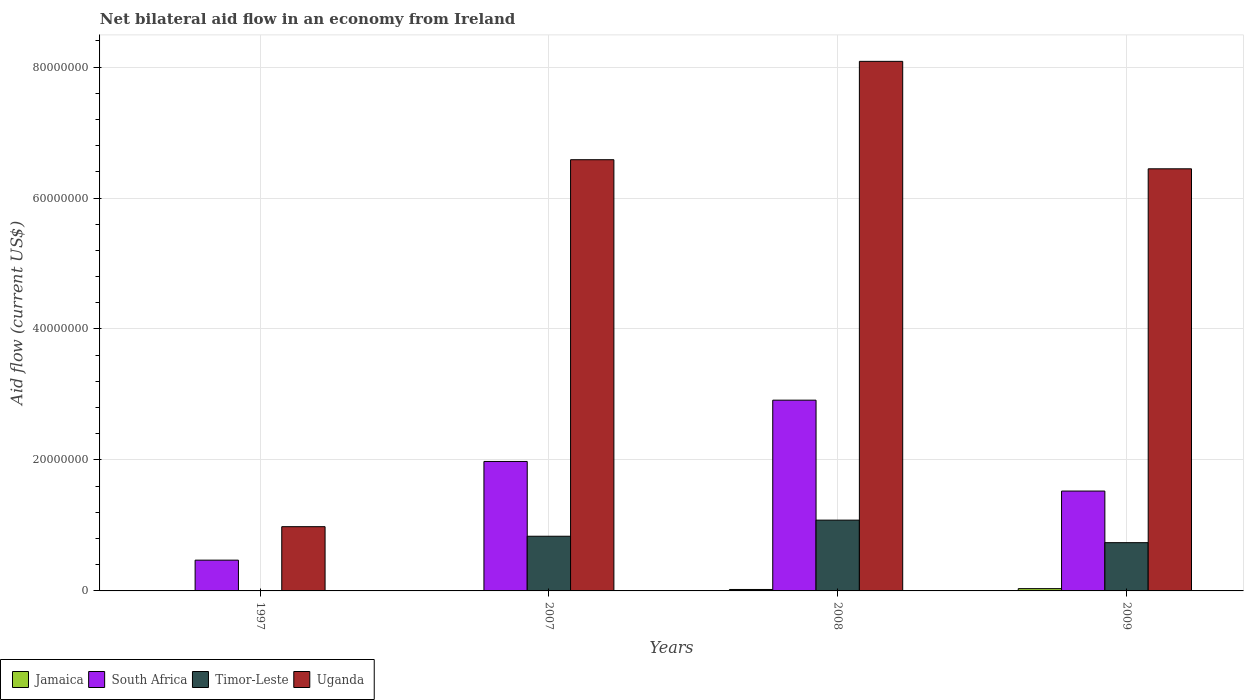Are the number of bars per tick equal to the number of legend labels?
Provide a succinct answer. Yes. Are the number of bars on each tick of the X-axis equal?
Make the answer very short. Yes. How many bars are there on the 2nd tick from the left?
Offer a very short reply. 4. How many bars are there on the 1st tick from the right?
Provide a succinct answer. 4. What is the label of the 3rd group of bars from the left?
Your answer should be very brief. 2008. In how many cases, is the number of bars for a given year not equal to the number of legend labels?
Offer a very short reply. 0. Across all years, what is the maximum net bilateral aid flow in Timor-Leste?
Provide a succinct answer. 1.08e+07. In which year was the net bilateral aid flow in Uganda minimum?
Your answer should be compact. 1997. What is the total net bilateral aid flow in South Africa in the graph?
Ensure brevity in your answer.  6.88e+07. What is the difference between the net bilateral aid flow in Timor-Leste in 1997 and that in 2007?
Provide a short and direct response. -8.30e+06. What is the difference between the net bilateral aid flow in Timor-Leste in 2008 and the net bilateral aid flow in Uganda in 1997?
Keep it short and to the point. 1.00e+06. What is the average net bilateral aid flow in Jamaica per year?
Give a very brief answer. 1.65e+05. In the year 2009, what is the difference between the net bilateral aid flow in Jamaica and net bilateral aid flow in Uganda?
Provide a short and direct response. -6.41e+07. What is the ratio of the net bilateral aid flow in Uganda in 1997 to that in 2008?
Provide a succinct answer. 0.12. What is the difference between the highest and the second highest net bilateral aid flow in Timor-Leste?
Provide a succinct answer. 2.46e+06. What is the difference between the highest and the lowest net bilateral aid flow in Timor-Leste?
Offer a very short reply. 1.08e+07. What does the 2nd bar from the left in 2008 represents?
Your answer should be compact. South Africa. What does the 4th bar from the right in 2008 represents?
Offer a terse response. Jamaica. Is it the case that in every year, the sum of the net bilateral aid flow in South Africa and net bilateral aid flow in Jamaica is greater than the net bilateral aid flow in Timor-Leste?
Offer a terse response. Yes. How many bars are there?
Provide a succinct answer. 16. Are the values on the major ticks of Y-axis written in scientific E-notation?
Offer a very short reply. No. Does the graph contain any zero values?
Offer a very short reply. No. Does the graph contain grids?
Provide a succinct answer. Yes. How many legend labels are there?
Provide a succinct answer. 4. What is the title of the graph?
Ensure brevity in your answer.  Net bilateral aid flow in an economy from Ireland. Does "Cyprus" appear as one of the legend labels in the graph?
Give a very brief answer. No. What is the label or title of the X-axis?
Your response must be concise. Years. What is the label or title of the Y-axis?
Keep it short and to the point. Aid flow (current US$). What is the Aid flow (current US$) in South Africa in 1997?
Your answer should be compact. 4.70e+06. What is the Aid flow (current US$) in Timor-Leste in 1997?
Keep it short and to the point. 5.00e+04. What is the Aid flow (current US$) of Uganda in 1997?
Provide a succinct answer. 9.81e+06. What is the Aid flow (current US$) of Jamaica in 2007?
Provide a succinct answer. 4.00e+04. What is the Aid flow (current US$) in South Africa in 2007?
Ensure brevity in your answer.  1.98e+07. What is the Aid flow (current US$) in Timor-Leste in 2007?
Keep it short and to the point. 8.35e+06. What is the Aid flow (current US$) of Uganda in 2007?
Your answer should be very brief. 6.58e+07. What is the Aid flow (current US$) in Jamaica in 2008?
Provide a succinct answer. 2.20e+05. What is the Aid flow (current US$) of South Africa in 2008?
Offer a terse response. 2.91e+07. What is the Aid flow (current US$) in Timor-Leste in 2008?
Your answer should be very brief. 1.08e+07. What is the Aid flow (current US$) of Uganda in 2008?
Your response must be concise. 8.09e+07. What is the Aid flow (current US$) in South Africa in 2009?
Keep it short and to the point. 1.52e+07. What is the Aid flow (current US$) in Timor-Leste in 2009?
Give a very brief answer. 7.37e+06. What is the Aid flow (current US$) of Uganda in 2009?
Provide a succinct answer. 6.45e+07. Across all years, what is the maximum Aid flow (current US$) of South Africa?
Your answer should be compact. 2.91e+07. Across all years, what is the maximum Aid flow (current US$) in Timor-Leste?
Keep it short and to the point. 1.08e+07. Across all years, what is the maximum Aid flow (current US$) of Uganda?
Provide a short and direct response. 8.09e+07. Across all years, what is the minimum Aid flow (current US$) in Jamaica?
Make the answer very short. 4.00e+04. Across all years, what is the minimum Aid flow (current US$) of South Africa?
Your answer should be compact. 4.70e+06. Across all years, what is the minimum Aid flow (current US$) of Timor-Leste?
Make the answer very short. 5.00e+04. Across all years, what is the minimum Aid flow (current US$) of Uganda?
Your answer should be compact. 9.81e+06. What is the total Aid flow (current US$) in Jamaica in the graph?
Your answer should be compact. 6.60e+05. What is the total Aid flow (current US$) in South Africa in the graph?
Keep it short and to the point. 6.88e+07. What is the total Aid flow (current US$) of Timor-Leste in the graph?
Ensure brevity in your answer.  2.66e+07. What is the total Aid flow (current US$) of Uganda in the graph?
Offer a terse response. 2.21e+08. What is the difference between the Aid flow (current US$) in Jamaica in 1997 and that in 2007?
Keep it short and to the point. 10000. What is the difference between the Aid flow (current US$) of South Africa in 1997 and that in 2007?
Give a very brief answer. -1.51e+07. What is the difference between the Aid flow (current US$) in Timor-Leste in 1997 and that in 2007?
Offer a terse response. -8.30e+06. What is the difference between the Aid flow (current US$) in Uganda in 1997 and that in 2007?
Your response must be concise. -5.60e+07. What is the difference between the Aid flow (current US$) in Jamaica in 1997 and that in 2008?
Offer a very short reply. -1.70e+05. What is the difference between the Aid flow (current US$) in South Africa in 1997 and that in 2008?
Provide a short and direct response. -2.44e+07. What is the difference between the Aid flow (current US$) in Timor-Leste in 1997 and that in 2008?
Your response must be concise. -1.08e+07. What is the difference between the Aid flow (current US$) in Uganda in 1997 and that in 2008?
Make the answer very short. -7.11e+07. What is the difference between the Aid flow (current US$) of South Africa in 1997 and that in 2009?
Give a very brief answer. -1.06e+07. What is the difference between the Aid flow (current US$) of Timor-Leste in 1997 and that in 2009?
Offer a very short reply. -7.32e+06. What is the difference between the Aid flow (current US$) in Uganda in 1997 and that in 2009?
Provide a succinct answer. -5.46e+07. What is the difference between the Aid flow (current US$) in South Africa in 2007 and that in 2008?
Offer a terse response. -9.36e+06. What is the difference between the Aid flow (current US$) in Timor-Leste in 2007 and that in 2008?
Offer a very short reply. -2.46e+06. What is the difference between the Aid flow (current US$) of Uganda in 2007 and that in 2008?
Ensure brevity in your answer.  -1.50e+07. What is the difference between the Aid flow (current US$) of Jamaica in 2007 and that in 2009?
Offer a very short reply. -3.10e+05. What is the difference between the Aid flow (current US$) in South Africa in 2007 and that in 2009?
Provide a succinct answer. 4.52e+06. What is the difference between the Aid flow (current US$) in Timor-Leste in 2007 and that in 2009?
Your answer should be very brief. 9.80e+05. What is the difference between the Aid flow (current US$) of Uganda in 2007 and that in 2009?
Offer a very short reply. 1.39e+06. What is the difference between the Aid flow (current US$) in South Africa in 2008 and that in 2009?
Your answer should be very brief. 1.39e+07. What is the difference between the Aid flow (current US$) of Timor-Leste in 2008 and that in 2009?
Make the answer very short. 3.44e+06. What is the difference between the Aid flow (current US$) of Uganda in 2008 and that in 2009?
Your answer should be very brief. 1.64e+07. What is the difference between the Aid flow (current US$) in Jamaica in 1997 and the Aid flow (current US$) in South Africa in 2007?
Make the answer very short. -1.97e+07. What is the difference between the Aid flow (current US$) in Jamaica in 1997 and the Aid flow (current US$) in Timor-Leste in 2007?
Provide a succinct answer. -8.30e+06. What is the difference between the Aid flow (current US$) of Jamaica in 1997 and the Aid flow (current US$) of Uganda in 2007?
Provide a short and direct response. -6.58e+07. What is the difference between the Aid flow (current US$) of South Africa in 1997 and the Aid flow (current US$) of Timor-Leste in 2007?
Offer a terse response. -3.65e+06. What is the difference between the Aid flow (current US$) in South Africa in 1997 and the Aid flow (current US$) in Uganda in 2007?
Your answer should be compact. -6.12e+07. What is the difference between the Aid flow (current US$) of Timor-Leste in 1997 and the Aid flow (current US$) of Uganda in 2007?
Make the answer very short. -6.58e+07. What is the difference between the Aid flow (current US$) of Jamaica in 1997 and the Aid flow (current US$) of South Africa in 2008?
Provide a short and direct response. -2.91e+07. What is the difference between the Aid flow (current US$) in Jamaica in 1997 and the Aid flow (current US$) in Timor-Leste in 2008?
Your response must be concise. -1.08e+07. What is the difference between the Aid flow (current US$) of Jamaica in 1997 and the Aid flow (current US$) of Uganda in 2008?
Ensure brevity in your answer.  -8.08e+07. What is the difference between the Aid flow (current US$) of South Africa in 1997 and the Aid flow (current US$) of Timor-Leste in 2008?
Your answer should be very brief. -6.11e+06. What is the difference between the Aid flow (current US$) of South Africa in 1997 and the Aid flow (current US$) of Uganda in 2008?
Provide a succinct answer. -7.62e+07. What is the difference between the Aid flow (current US$) of Timor-Leste in 1997 and the Aid flow (current US$) of Uganda in 2008?
Offer a terse response. -8.08e+07. What is the difference between the Aid flow (current US$) of Jamaica in 1997 and the Aid flow (current US$) of South Africa in 2009?
Keep it short and to the point. -1.52e+07. What is the difference between the Aid flow (current US$) in Jamaica in 1997 and the Aid flow (current US$) in Timor-Leste in 2009?
Your response must be concise. -7.32e+06. What is the difference between the Aid flow (current US$) of Jamaica in 1997 and the Aid flow (current US$) of Uganda in 2009?
Give a very brief answer. -6.44e+07. What is the difference between the Aid flow (current US$) in South Africa in 1997 and the Aid flow (current US$) in Timor-Leste in 2009?
Offer a terse response. -2.67e+06. What is the difference between the Aid flow (current US$) in South Africa in 1997 and the Aid flow (current US$) in Uganda in 2009?
Your answer should be compact. -5.98e+07. What is the difference between the Aid flow (current US$) in Timor-Leste in 1997 and the Aid flow (current US$) in Uganda in 2009?
Give a very brief answer. -6.44e+07. What is the difference between the Aid flow (current US$) in Jamaica in 2007 and the Aid flow (current US$) in South Africa in 2008?
Offer a terse response. -2.91e+07. What is the difference between the Aid flow (current US$) in Jamaica in 2007 and the Aid flow (current US$) in Timor-Leste in 2008?
Your answer should be compact. -1.08e+07. What is the difference between the Aid flow (current US$) of Jamaica in 2007 and the Aid flow (current US$) of Uganda in 2008?
Your response must be concise. -8.08e+07. What is the difference between the Aid flow (current US$) of South Africa in 2007 and the Aid flow (current US$) of Timor-Leste in 2008?
Your response must be concise. 8.96e+06. What is the difference between the Aid flow (current US$) in South Africa in 2007 and the Aid flow (current US$) in Uganda in 2008?
Make the answer very short. -6.11e+07. What is the difference between the Aid flow (current US$) in Timor-Leste in 2007 and the Aid flow (current US$) in Uganda in 2008?
Give a very brief answer. -7.25e+07. What is the difference between the Aid flow (current US$) in Jamaica in 2007 and the Aid flow (current US$) in South Africa in 2009?
Make the answer very short. -1.52e+07. What is the difference between the Aid flow (current US$) in Jamaica in 2007 and the Aid flow (current US$) in Timor-Leste in 2009?
Offer a terse response. -7.33e+06. What is the difference between the Aid flow (current US$) of Jamaica in 2007 and the Aid flow (current US$) of Uganda in 2009?
Offer a terse response. -6.44e+07. What is the difference between the Aid flow (current US$) of South Africa in 2007 and the Aid flow (current US$) of Timor-Leste in 2009?
Give a very brief answer. 1.24e+07. What is the difference between the Aid flow (current US$) in South Africa in 2007 and the Aid flow (current US$) in Uganda in 2009?
Your response must be concise. -4.47e+07. What is the difference between the Aid flow (current US$) of Timor-Leste in 2007 and the Aid flow (current US$) of Uganda in 2009?
Your response must be concise. -5.61e+07. What is the difference between the Aid flow (current US$) of Jamaica in 2008 and the Aid flow (current US$) of South Africa in 2009?
Keep it short and to the point. -1.50e+07. What is the difference between the Aid flow (current US$) in Jamaica in 2008 and the Aid flow (current US$) in Timor-Leste in 2009?
Make the answer very short. -7.15e+06. What is the difference between the Aid flow (current US$) in Jamaica in 2008 and the Aid flow (current US$) in Uganda in 2009?
Make the answer very short. -6.42e+07. What is the difference between the Aid flow (current US$) in South Africa in 2008 and the Aid flow (current US$) in Timor-Leste in 2009?
Offer a very short reply. 2.18e+07. What is the difference between the Aid flow (current US$) of South Africa in 2008 and the Aid flow (current US$) of Uganda in 2009?
Your answer should be compact. -3.53e+07. What is the difference between the Aid flow (current US$) of Timor-Leste in 2008 and the Aid flow (current US$) of Uganda in 2009?
Your response must be concise. -5.36e+07. What is the average Aid flow (current US$) of Jamaica per year?
Your response must be concise. 1.65e+05. What is the average Aid flow (current US$) in South Africa per year?
Give a very brief answer. 1.72e+07. What is the average Aid flow (current US$) in Timor-Leste per year?
Make the answer very short. 6.64e+06. What is the average Aid flow (current US$) in Uganda per year?
Your response must be concise. 5.52e+07. In the year 1997, what is the difference between the Aid flow (current US$) of Jamaica and Aid flow (current US$) of South Africa?
Your response must be concise. -4.65e+06. In the year 1997, what is the difference between the Aid flow (current US$) in Jamaica and Aid flow (current US$) in Timor-Leste?
Make the answer very short. 0. In the year 1997, what is the difference between the Aid flow (current US$) of Jamaica and Aid flow (current US$) of Uganda?
Your response must be concise. -9.76e+06. In the year 1997, what is the difference between the Aid flow (current US$) of South Africa and Aid flow (current US$) of Timor-Leste?
Keep it short and to the point. 4.65e+06. In the year 1997, what is the difference between the Aid flow (current US$) of South Africa and Aid flow (current US$) of Uganda?
Offer a very short reply. -5.11e+06. In the year 1997, what is the difference between the Aid flow (current US$) in Timor-Leste and Aid flow (current US$) in Uganda?
Give a very brief answer. -9.76e+06. In the year 2007, what is the difference between the Aid flow (current US$) of Jamaica and Aid flow (current US$) of South Africa?
Your answer should be compact. -1.97e+07. In the year 2007, what is the difference between the Aid flow (current US$) of Jamaica and Aid flow (current US$) of Timor-Leste?
Your answer should be compact. -8.31e+06. In the year 2007, what is the difference between the Aid flow (current US$) of Jamaica and Aid flow (current US$) of Uganda?
Ensure brevity in your answer.  -6.58e+07. In the year 2007, what is the difference between the Aid flow (current US$) in South Africa and Aid flow (current US$) in Timor-Leste?
Give a very brief answer. 1.14e+07. In the year 2007, what is the difference between the Aid flow (current US$) of South Africa and Aid flow (current US$) of Uganda?
Provide a succinct answer. -4.61e+07. In the year 2007, what is the difference between the Aid flow (current US$) in Timor-Leste and Aid flow (current US$) in Uganda?
Offer a terse response. -5.75e+07. In the year 2008, what is the difference between the Aid flow (current US$) of Jamaica and Aid flow (current US$) of South Africa?
Give a very brief answer. -2.89e+07. In the year 2008, what is the difference between the Aid flow (current US$) of Jamaica and Aid flow (current US$) of Timor-Leste?
Ensure brevity in your answer.  -1.06e+07. In the year 2008, what is the difference between the Aid flow (current US$) in Jamaica and Aid flow (current US$) in Uganda?
Provide a short and direct response. -8.06e+07. In the year 2008, what is the difference between the Aid flow (current US$) in South Africa and Aid flow (current US$) in Timor-Leste?
Provide a succinct answer. 1.83e+07. In the year 2008, what is the difference between the Aid flow (current US$) of South Africa and Aid flow (current US$) of Uganda?
Provide a short and direct response. -5.17e+07. In the year 2008, what is the difference between the Aid flow (current US$) in Timor-Leste and Aid flow (current US$) in Uganda?
Your answer should be very brief. -7.01e+07. In the year 2009, what is the difference between the Aid flow (current US$) of Jamaica and Aid flow (current US$) of South Africa?
Your response must be concise. -1.49e+07. In the year 2009, what is the difference between the Aid flow (current US$) of Jamaica and Aid flow (current US$) of Timor-Leste?
Provide a short and direct response. -7.02e+06. In the year 2009, what is the difference between the Aid flow (current US$) in Jamaica and Aid flow (current US$) in Uganda?
Your response must be concise. -6.41e+07. In the year 2009, what is the difference between the Aid flow (current US$) of South Africa and Aid flow (current US$) of Timor-Leste?
Keep it short and to the point. 7.88e+06. In the year 2009, what is the difference between the Aid flow (current US$) of South Africa and Aid flow (current US$) of Uganda?
Keep it short and to the point. -4.92e+07. In the year 2009, what is the difference between the Aid flow (current US$) of Timor-Leste and Aid flow (current US$) of Uganda?
Provide a short and direct response. -5.71e+07. What is the ratio of the Aid flow (current US$) of Jamaica in 1997 to that in 2007?
Your answer should be compact. 1.25. What is the ratio of the Aid flow (current US$) in South Africa in 1997 to that in 2007?
Give a very brief answer. 0.24. What is the ratio of the Aid flow (current US$) of Timor-Leste in 1997 to that in 2007?
Provide a succinct answer. 0.01. What is the ratio of the Aid flow (current US$) of Uganda in 1997 to that in 2007?
Give a very brief answer. 0.15. What is the ratio of the Aid flow (current US$) of Jamaica in 1997 to that in 2008?
Provide a short and direct response. 0.23. What is the ratio of the Aid flow (current US$) in South Africa in 1997 to that in 2008?
Provide a short and direct response. 0.16. What is the ratio of the Aid flow (current US$) in Timor-Leste in 1997 to that in 2008?
Make the answer very short. 0. What is the ratio of the Aid flow (current US$) in Uganda in 1997 to that in 2008?
Your answer should be compact. 0.12. What is the ratio of the Aid flow (current US$) in Jamaica in 1997 to that in 2009?
Offer a terse response. 0.14. What is the ratio of the Aid flow (current US$) in South Africa in 1997 to that in 2009?
Give a very brief answer. 0.31. What is the ratio of the Aid flow (current US$) in Timor-Leste in 1997 to that in 2009?
Ensure brevity in your answer.  0.01. What is the ratio of the Aid flow (current US$) of Uganda in 1997 to that in 2009?
Give a very brief answer. 0.15. What is the ratio of the Aid flow (current US$) of Jamaica in 2007 to that in 2008?
Offer a terse response. 0.18. What is the ratio of the Aid flow (current US$) in South Africa in 2007 to that in 2008?
Ensure brevity in your answer.  0.68. What is the ratio of the Aid flow (current US$) in Timor-Leste in 2007 to that in 2008?
Offer a very short reply. 0.77. What is the ratio of the Aid flow (current US$) of Uganda in 2007 to that in 2008?
Your answer should be very brief. 0.81. What is the ratio of the Aid flow (current US$) of Jamaica in 2007 to that in 2009?
Your answer should be compact. 0.11. What is the ratio of the Aid flow (current US$) in South Africa in 2007 to that in 2009?
Offer a very short reply. 1.3. What is the ratio of the Aid flow (current US$) in Timor-Leste in 2007 to that in 2009?
Provide a short and direct response. 1.13. What is the ratio of the Aid flow (current US$) in Uganda in 2007 to that in 2009?
Provide a succinct answer. 1.02. What is the ratio of the Aid flow (current US$) of Jamaica in 2008 to that in 2009?
Provide a short and direct response. 0.63. What is the ratio of the Aid flow (current US$) of South Africa in 2008 to that in 2009?
Provide a succinct answer. 1.91. What is the ratio of the Aid flow (current US$) in Timor-Leste in 2008 to that in 2009?
Make the answer very short. 1.47. What is the ratio of the Aid flow (current US$) in Uganda in 2008 to that in 2009?
Keep it short and to the point. 1.25. What is the difference between the highest and the second highest Aid flow (current US$) of Jamaica?
Your answer should be very brief. 1.30e+05. What is the difference between the highest and the second highest Aid flow (current US$) of South Africa?
Offer a terse response. 9.36e+06. What is the difference between the highest and the second highest Aid flow (current US$) of Timor-Leste?
Offer a very short reply. 2.46e+06. What is the difference between the highest and the second highest Aid flow (current US$) of Uganda?
Your response must be concise. 1.50e+07. What is the difference between the highest and the lowest Aid flow (current US$) in Jamaica?
Ensure brevity in your answer.  3.10e+05. What is the difference between the highest and the lowest Aid flow (current US$) of South Africa?
Ensure brevity in your answer.  2.44e+07. What is the difference between the highest and the lowest Aid flow (current US$) in Timor-Leste?
Your answer should be compact. 1.08e+07. What is the difference between the highest and the lowest Aid flow (current US$) in Uganda?
Provide a succinct answer. 7.11e+07. 